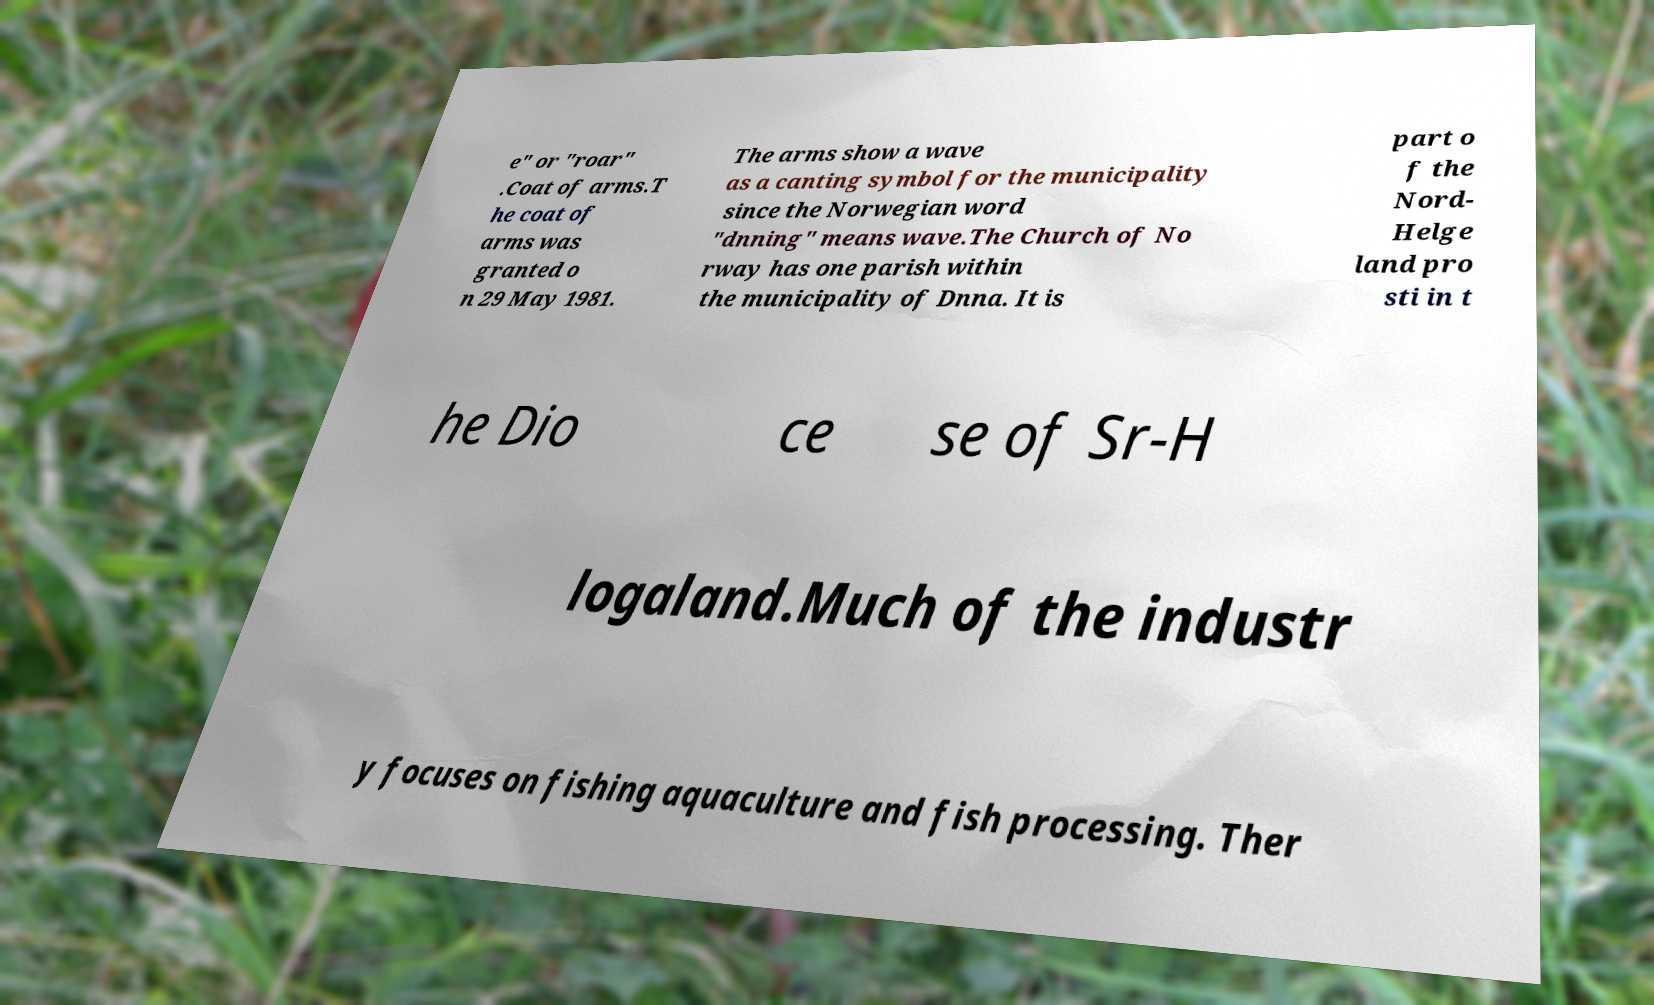There's text embedded in this image that I need extracted. Can you transcribe it verbatim? e" or "roar" .Coat of arms.T he coat of arms was granted o n 29 May 1981. The arms show a wave as a canting symbol for the municipality since the Norwegian word "dnning" means wave.The Church of No rway has one parish within the municipality of Dnna. It is part o f the Nord- Helge land pro sti in t he Dio ce se of Sr-H logaland.Much of the industr y focuses on fishing aquaculture and fish processing. Ther 